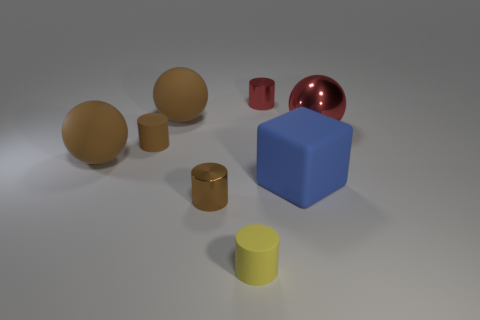Add 2 big balls. How many objects exist? 10 Subtract all cubes. How many objects are left? 7 Add 2 yellow cylinders. How many yellow cylinders are left? 3 Add 4 big rubber spheres. How many big rubber spheres exist? 6 Subtract 1 red cylinders. How many objects are left? 7 Subtract all tiny green shiny things. Subtract all small brown matte objects. How many objects are left? 7 